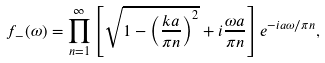<formula> <loc_0><loc_0><loc_500><loc_500>f _ { - } ( \omega ) = \prod _ { n = 1 } ^ { \infty } \left [ \sqrt { 1 - \left ( \frac { k a } { \pi n } \right ) ^ { 2 } } + i \frac { \omega a } { \pi n } \right ] e ^ { - i a \omega / \pi n } ,</formula> 